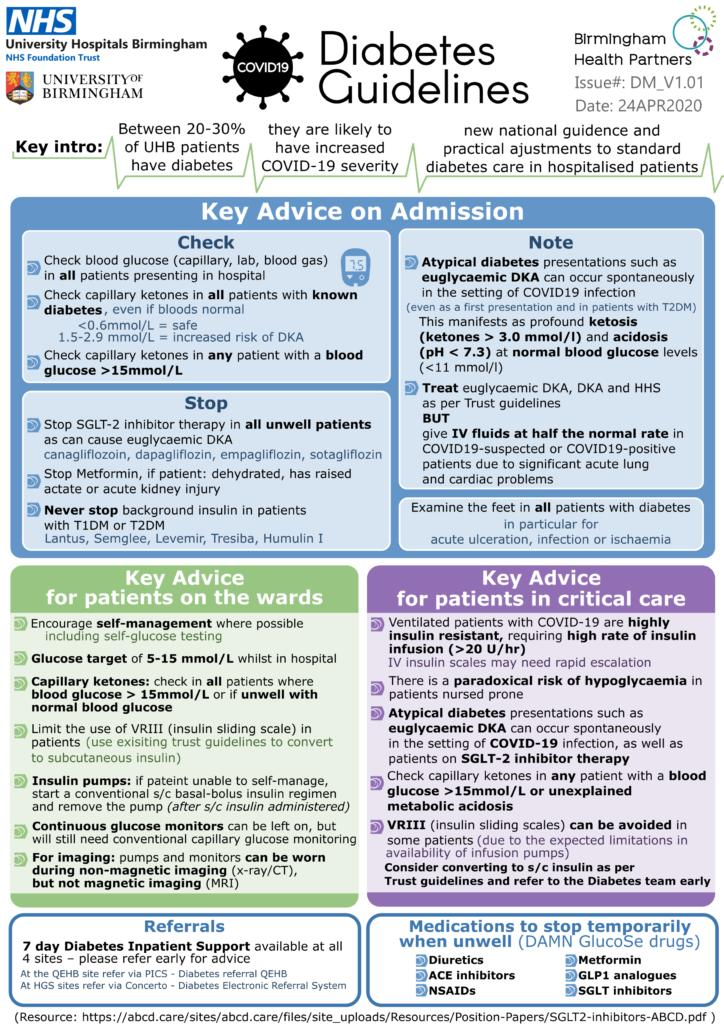Point out several critical features in this image. At the University Hospitals Birmingham, approximately 20-30% of patients have diabetes. Self-glucose testing is a valuable tool for encouraging self-management in patients with diabetes. It is likely that diabetes will increase the severity of COVID-19. Diabetic patients may exhibit a range of symptoms in their feet, including acute ulceration, infection, and ischemia. These symptoms can result in serious complications if left untreated, and it is important for diabetic patients to be aware of the potential signs and seek prompt medical attention if necessary. 